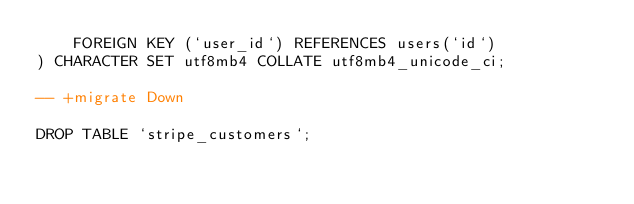<code> <loc_0><loc_0><loc_500><loc_500><_SQL_>    FOREIGN KEY (`user_id`) REFERENCES users(`id`)
) CHARACTER SET utf8mb4 COLLATE utf8mb4_unicode_ci;

-- +migrate Down

DROP TABLE `stripe_customers`;</code> 